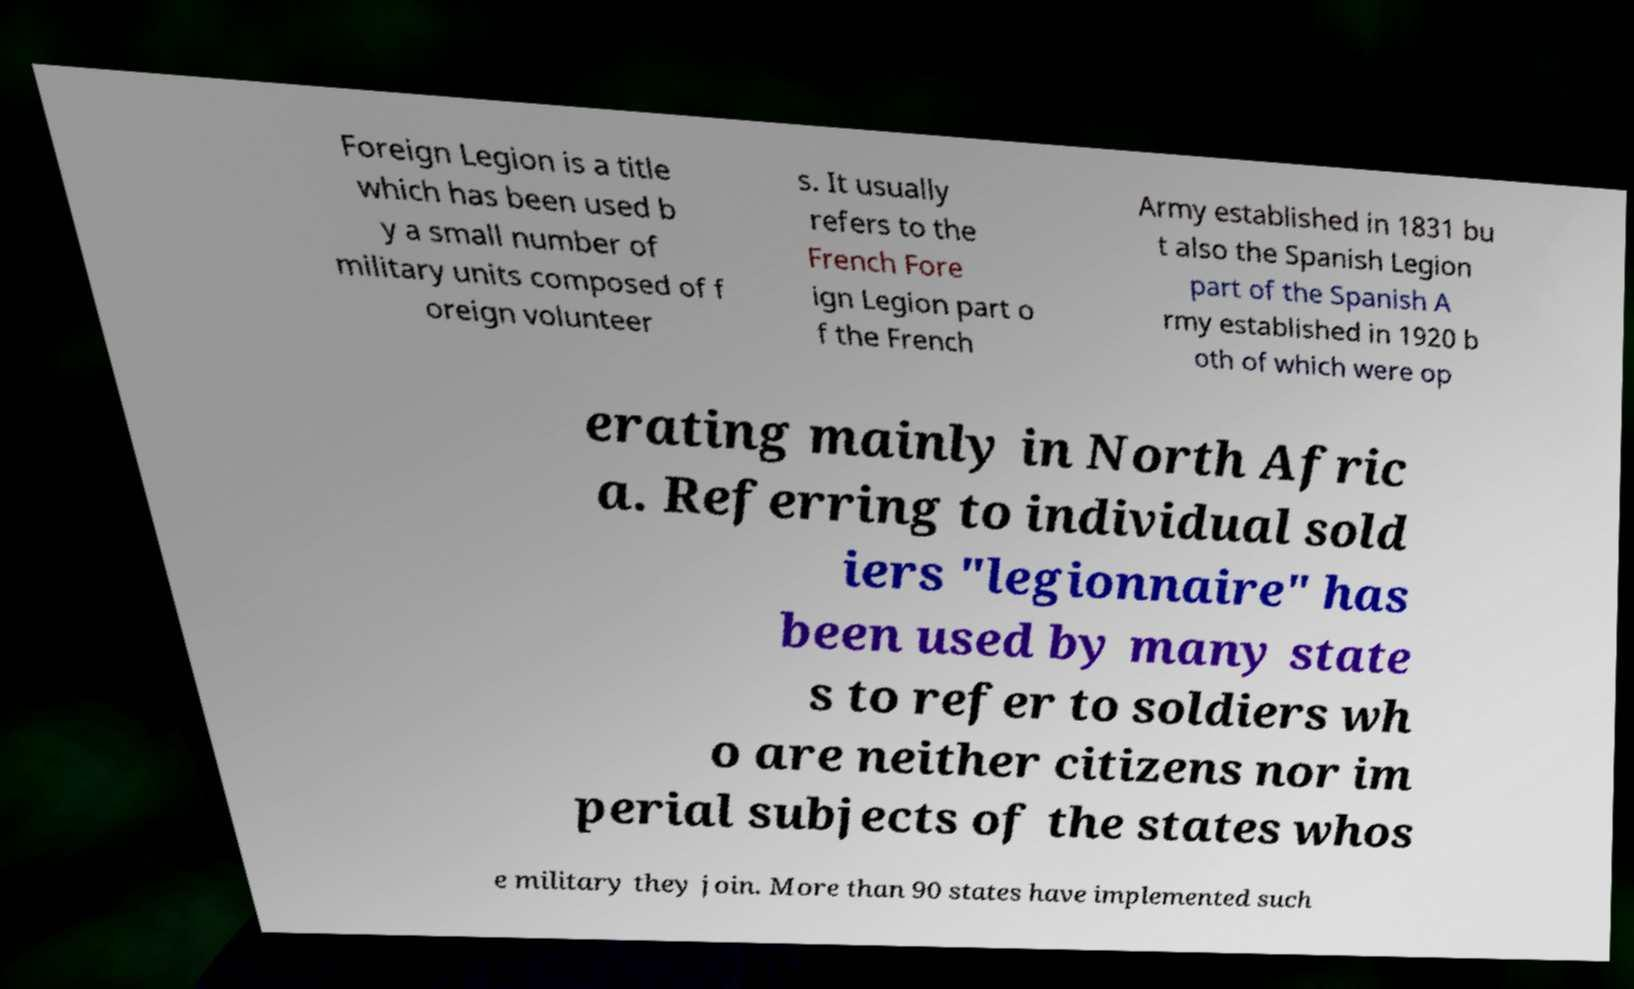What messages or text are displayed in this image? I need them in a readable, typed format. Foreign Legion is a title which has been used b y a small number of military units composed of f oreign volunteer s. It usually refers to the French Fore ign Legion part o f the French Army established in 1831 bu t also the Spanish Legion part of the Spanish A rmy established in 1920 b oth of which were op erating mainly in North Afric a. Referring to individual sold iers "legionnaire" has been used by many state s to refer to soldiers wh o are neither citizens nor im perial subjects of the states whos e military they join. More than 90 states have implemented such 